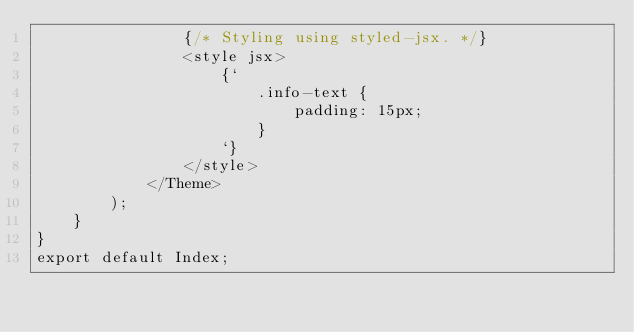<code> <loc_0><loc_0><loc_500><loc_500><_JavaScript_>				{/* Styling using styled-jsx. */}
				<style jsx>
					{`
						.info-text {
							padding: 15px;
						}
					`}
				</style>
			</Theme>
		);
	}
}
export default Index;
</code> 